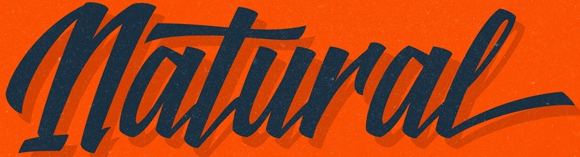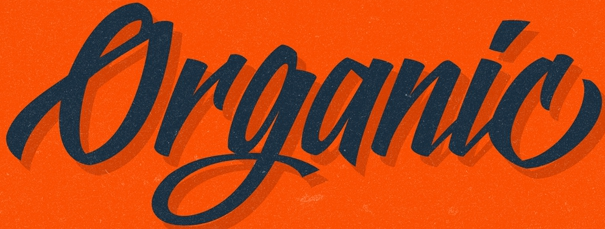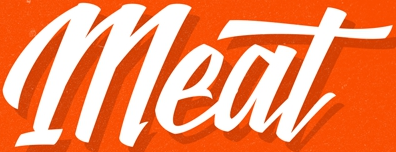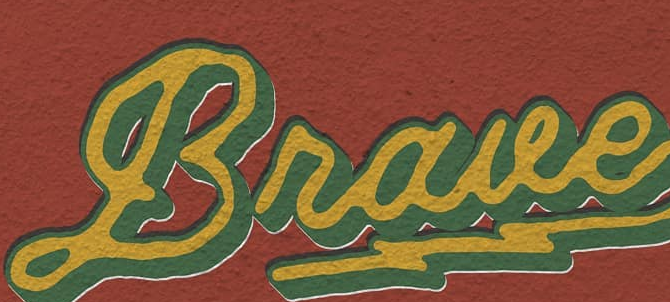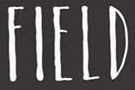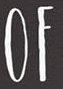Transcribe the words shown in these images in order, separated by a semicolon. Natural; Organic; Meat; Braue; FIELD; OF 